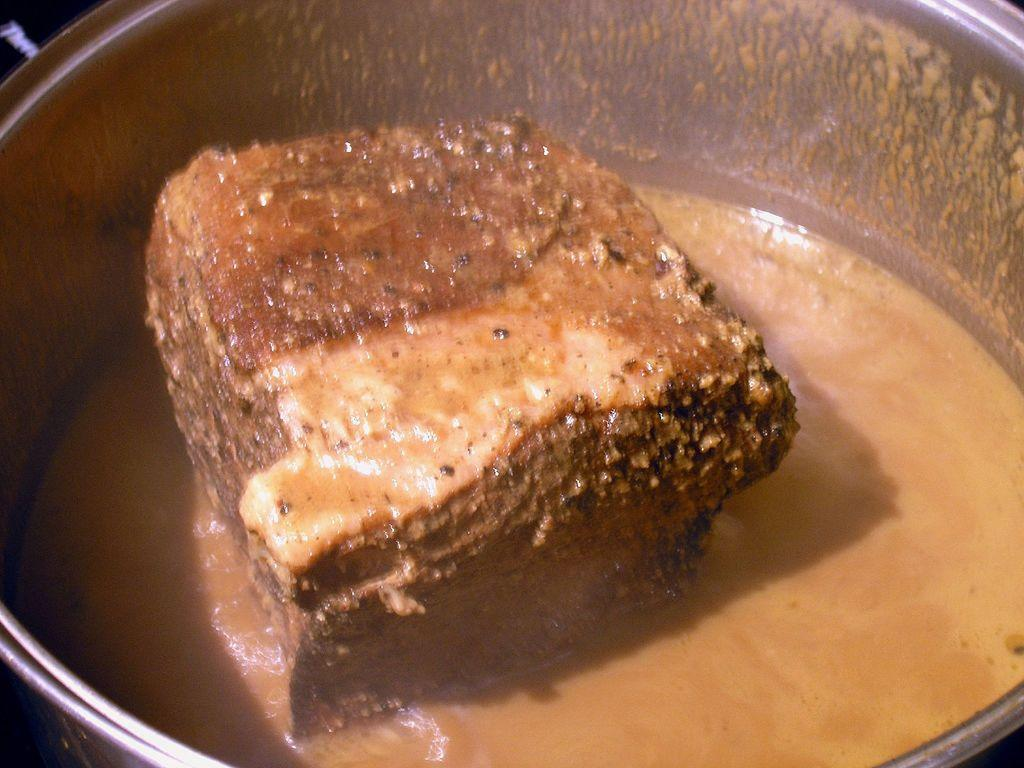What is present in the container that can be seen in the image? There is food in a container in the image. What type of class is being taught in the image? There is no class or teaching activity present in the image; it only shows food in a container. 